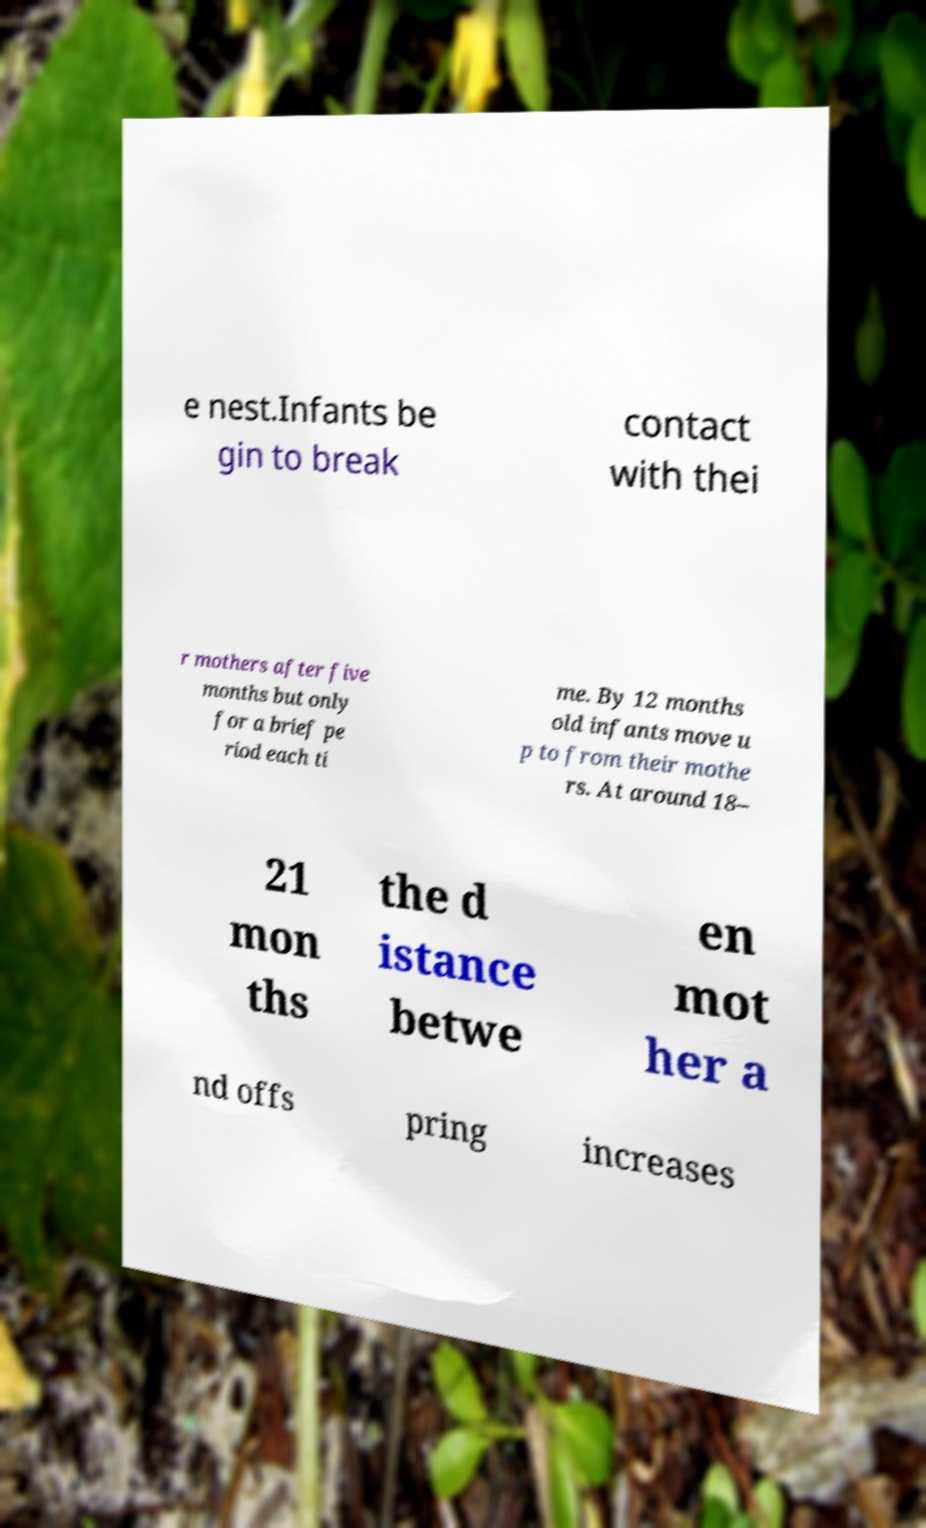Can you accurately transcribe the text from the provided image for me? e nest.Infants be gin to break contact with thei r mothers after five months but only for a brief pe riod each ti me. By 12 months old infants move u p to from their mothe rs. At around 18– 21 mon ths the d istance betwe en mot her a nd offs pring increases 